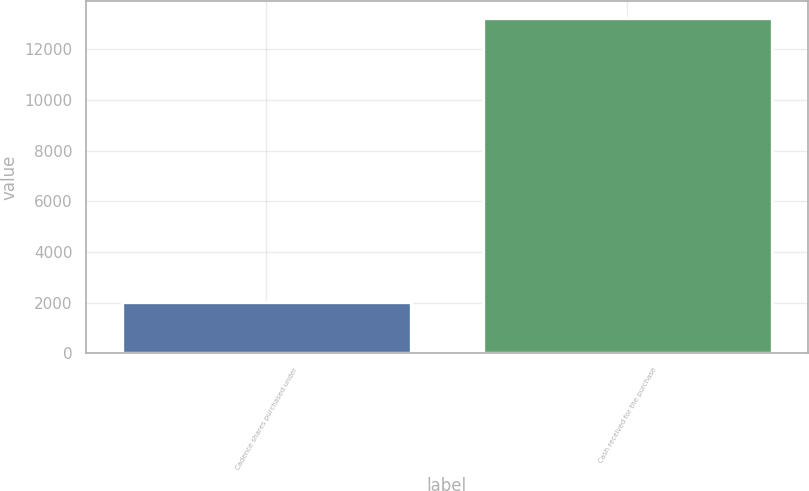Convert chart. <chart><loc_0><loc_0><loc_500><loc_500><bar_chart><fcel>Cadence shares purchased under<fcel>Cash received for the purchase<nl><fcel>2029<fcel>13236<nl></chart> 